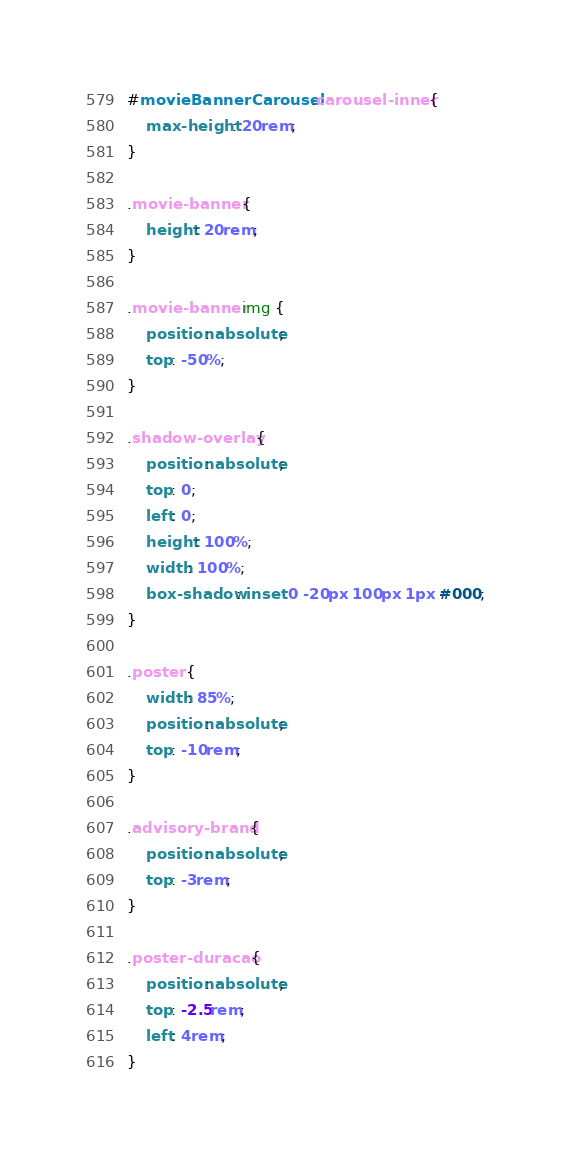Convert code to text. <code><loc_0><loc_0><loc_500><loc_500><_CSS_>#movieBannerCarousel .carousel-inner {
    max-height: 20rem;
}

.movie-banner {
    height: 20rem;
}

.movie-banner img {
    position: absolute;
    top: -50%;
}

.shadow-overlay {
    position: absolute;
    top: 0;
    left: 0;
    height: 100%;
    width: 100%;
    box-shadow: inset 0 -20px 100px 1px #000;
}

.poster {
    width: 85%;
    position: absolute;
    top: -10rem;
}

.advisory-brand {
    position: absolute;
    top: -3rem;
}

.poster-duracao {
    position: absolute;
    top: -2.5rem;
    left: 4rem;
}</code> 